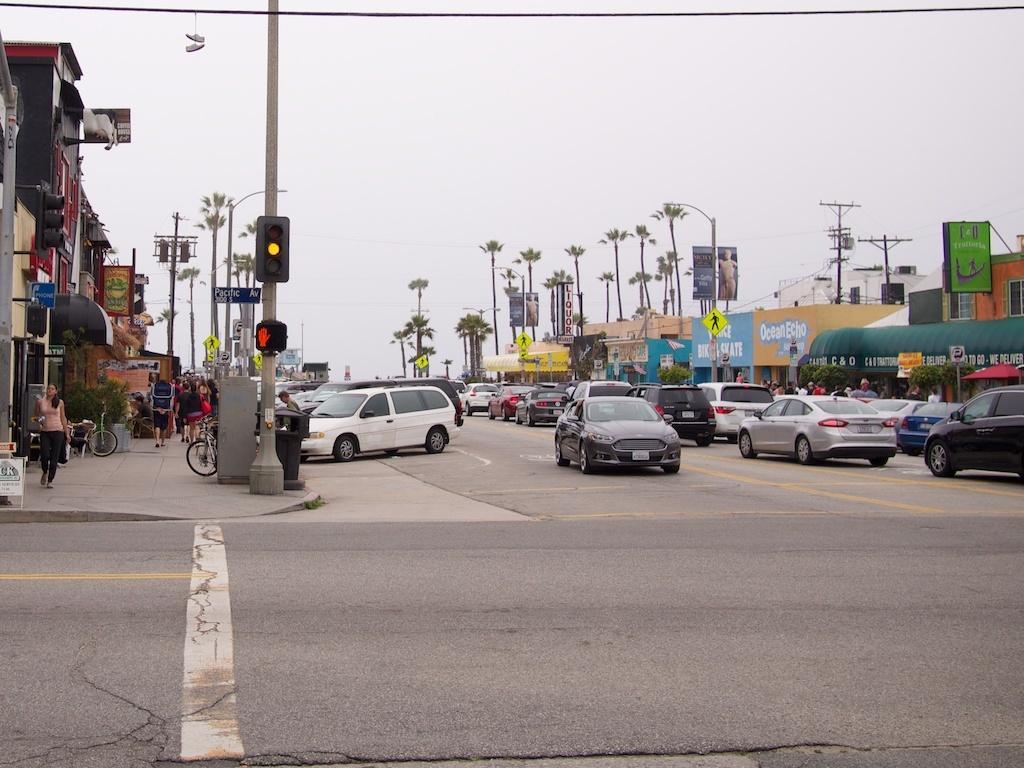How would you summarize this image in a sentence or two? This image is clicked on the road. There are vehicles moving on the road. Beside the road there is a walkway. There are cycles parked on the walkway. There are street light poles, traffic signal poles, dustbins and a few people walking on the walkway. On the either sides of the image there are buildings. There are boards with text on the buildings. In the background there are trees. At the top there is the sky. 